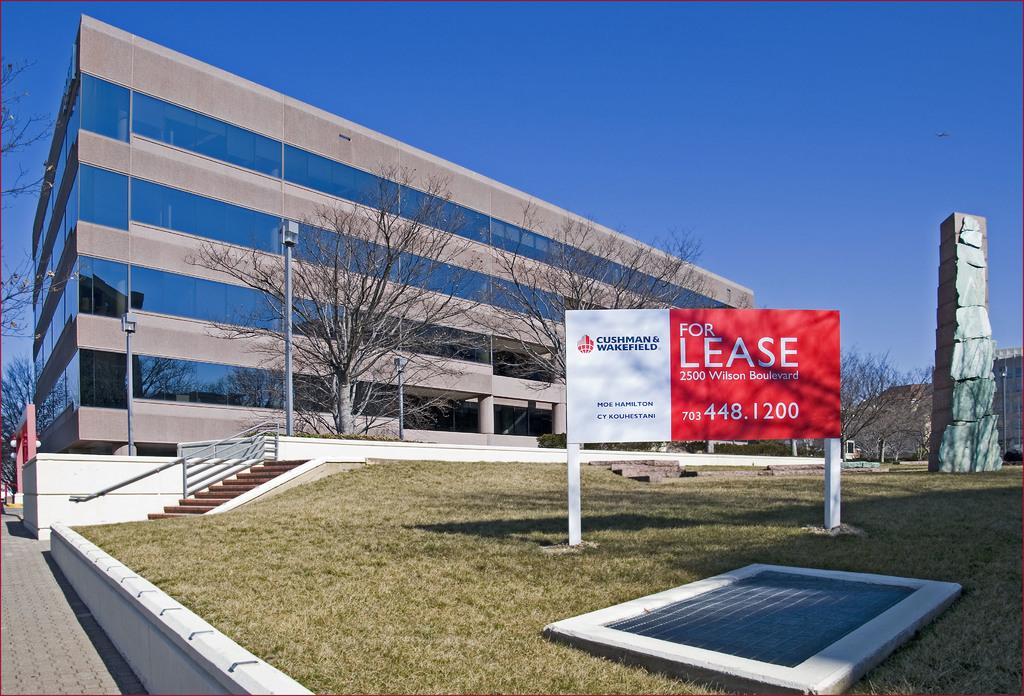How would you summarize this image in a sentence or two? In this image, I can see a building with the glass windows. In front of a building, I can see the trees, name board on the grass, stairs and light poles. On the right side of the image, this is a pillar. In the background, there is the sky. 